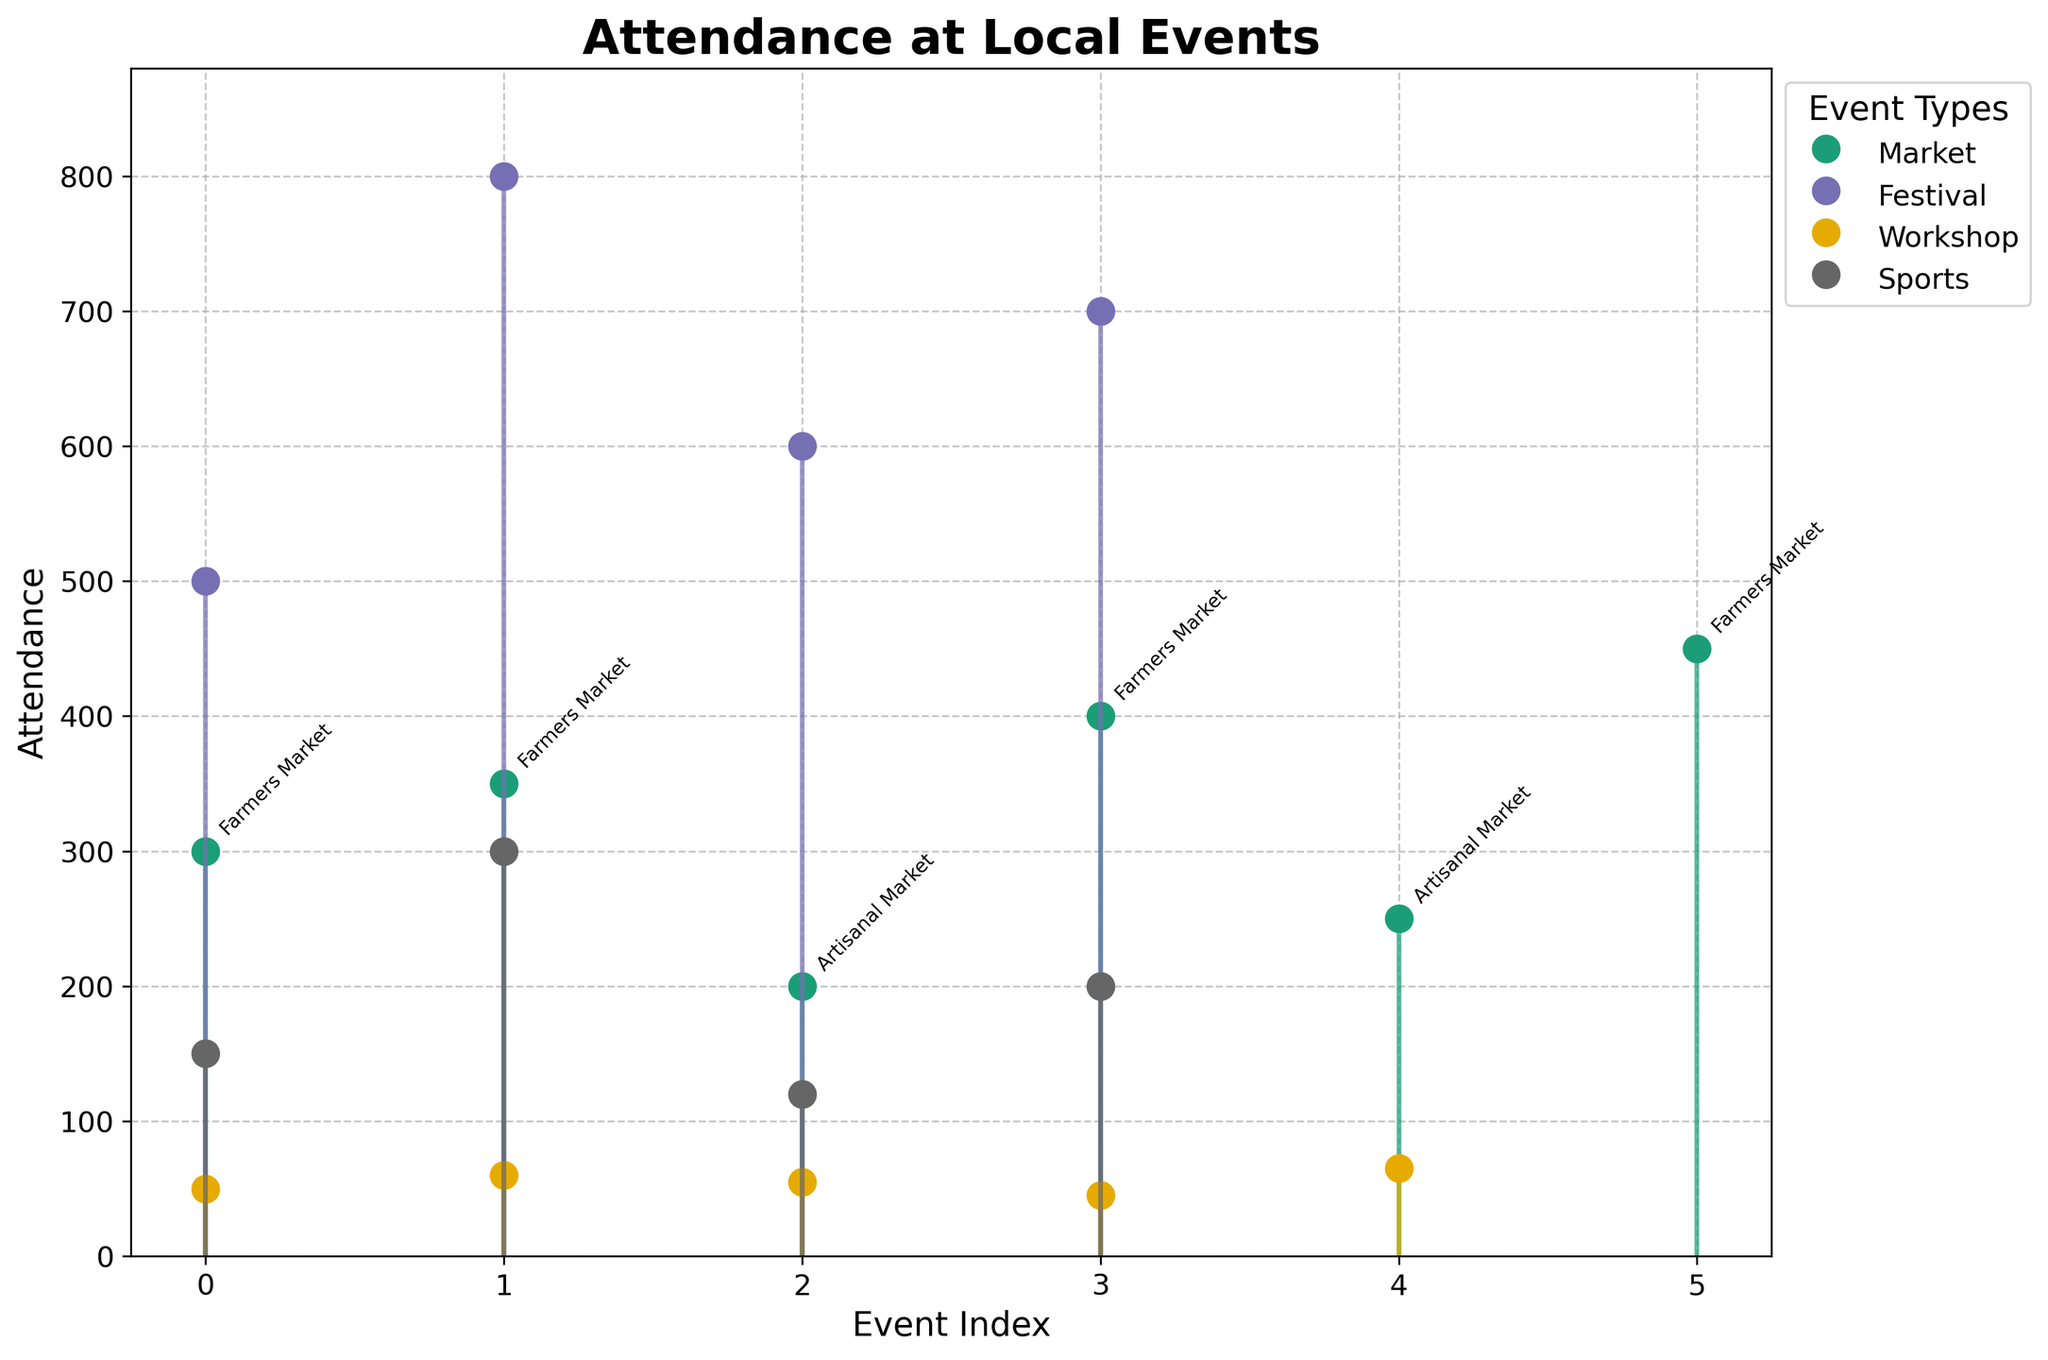What is the title of the plot? The title is prominently displayed at the top of the plot in large, bold font; it directly describes the content of the chart.
Answer: Attendance at Local Events How many event types are represented in the plot? Each unique event type is represented by a different color and labeled in the legend. By counting these unique labels, we find the number of event types.
Answer: Four Which event had the highest attendance? The plot's vertical axis represents attendance, with the highest point indicating the event with the highest attendance. The annotation near this peak provides the event name.
Answer: Music Festival What is the total attendance for all Workshops throughout the year? Select all the data points related to Workshops and sum their attendance figures. The events are Art Workshop (50), Gardening Workshop (60), Cooking Workshop (55), Technology Workshop (45), Writing Workshop (65). Total: 50 + 60 + 55 + 45 + 65.
Answer: 275 Which month had the greatest variation in attendance across different event types? By examining the plot, identify the month with the broadest range between the lowest and highest attendance values, considering multiple data points for the month. Note April and its variety in events and attendance figures.
Answer: April How does the attendance for Farmers Markets in January compare to June? Locate the attendance values for Farmers Markets in January and June on the plot and compare them directly.
Answer: January has 300, June has 450; June is higher Which type of event shows more consistent attendance numbers across the year? Review the spread and fluctuation of data points for each event type. Less variation suggests more consistency. Workshops show more consistent, closely clustered values compared to other event types.
Answer: Workshop What is the average attendance per event for Festivals? Sum the attendance for all Festivals and divide by the number of Festival events. Events are Spring Festival (500), Music Festival (800), Food Festival (600), Harvest Festival (700). Sum: 500 + 800 + 600 + 700 = 2600. Divide by 4: 2600 / 4.
Answer: 650 Is there any event with attendance below 50? Scan the vertical axis for attendance points below 50 and check the corresponding annotations. No data points fall below this threshold, suggesting no such events.
Answer: No Which event has the lowest attendance, and what was the attendance number? Identify the lowest point on the vertical axis and its associated annotation to find the event name and attendance.
Answer: Technology Workshop with 45 